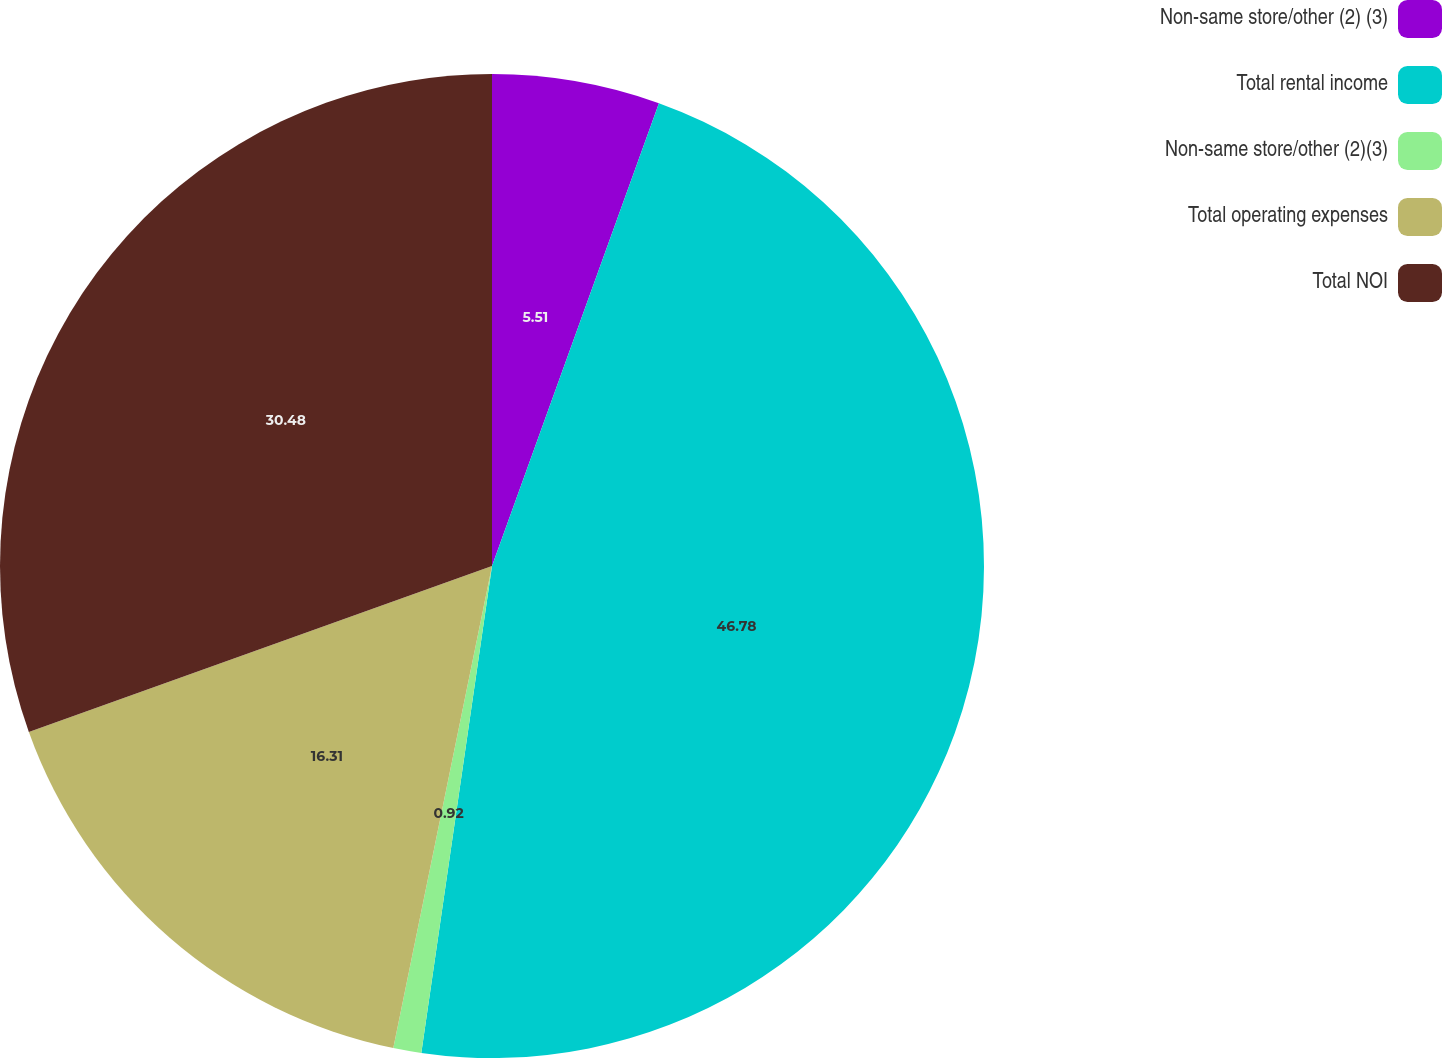Convert chart to OTSL. <chart><loc_0><loc_0><loc_500><loc_500><pie_chart><fcel>Non-same store/other (2) (3)<fcel>Total rental income<fcel>Non-same store/other (2)(3)<fcel>Total operating expenses<fcel>Total NOI<nl><fcel>5.51%<fcel>46.79%<fcel>0.92%<fcel>16.31%<fcel>30.48%<nl></chart> 